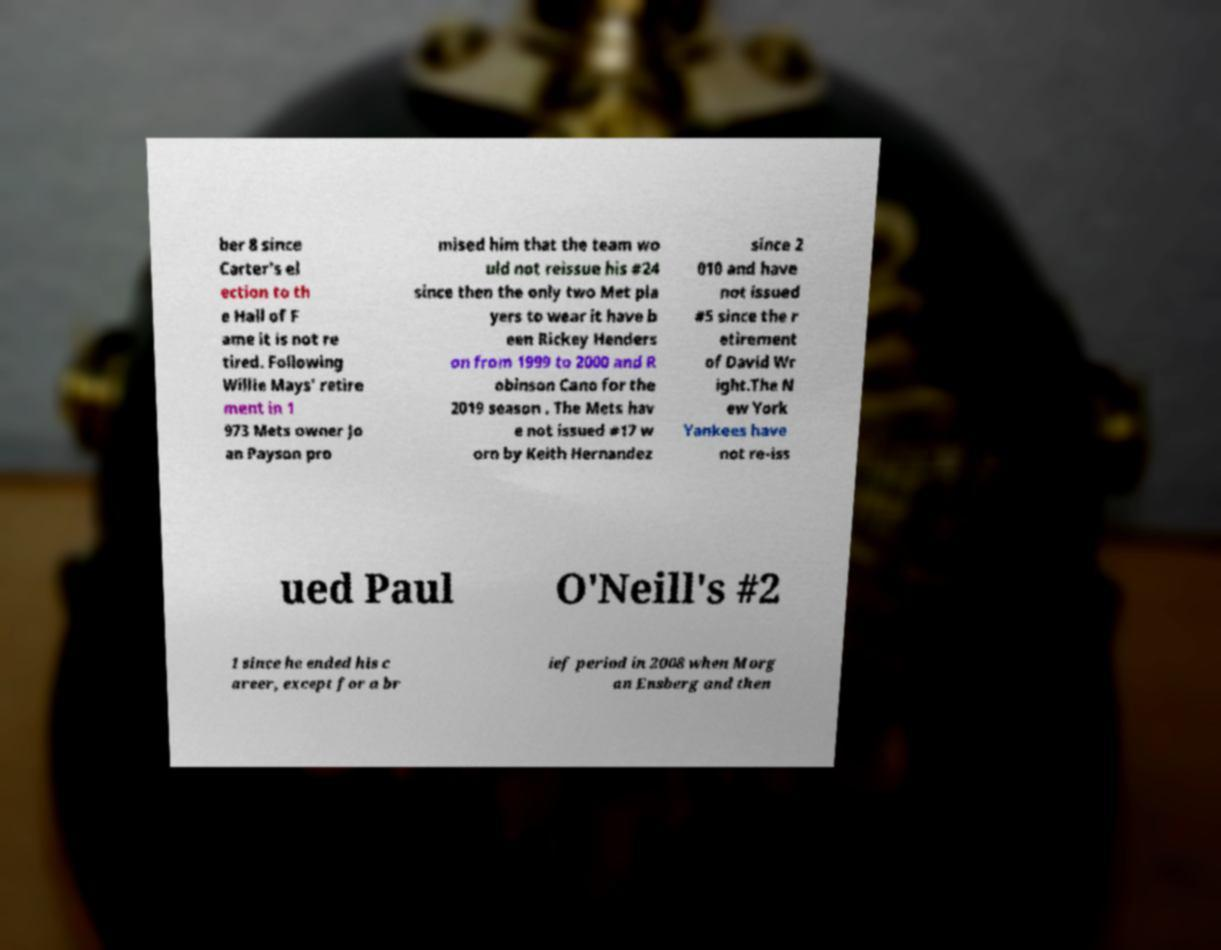Can you read and provide the text displayed in the image?This photo seems to have some interesting text. Can you extract and type it out for me? ber 8 since Carter's el ection to th e Hall of F ame it is not re tired. Following Willie Mays' retire ment in 1 973 Mets owner Jo an Payson pro mised him that the team wo uld not reissue his #24 since then the only two Met pla yers to wear it have b een Rickey Henders on from 1999 to 2000 and R obinson Cano for the 2019 season . The Mets hav e not issued #17 w orn by Keith Hernandez since 2 010 and have not issued #5 since the r etirement of David Wr ight.The N ew York Yankees have not re-iss ued Paul O'Neill's #2 1 since he ended his c areer, except for a br ief period in 2008 when Morg an Ensberg and then 